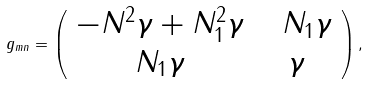Convert formula to latex. <formula><loc_0><loc_0><loc_500><loc_500>g _ { m n } = \left ( \begin{array} { c c } - N ^ { 2 } \gamma + N _ { 1 } ^ { 2 } \gamma & \ \ N _ { 1 } \gamma \\ N _ { 1 } \gamma & \gamma \\ \end{array} \right ) ,</formula> 